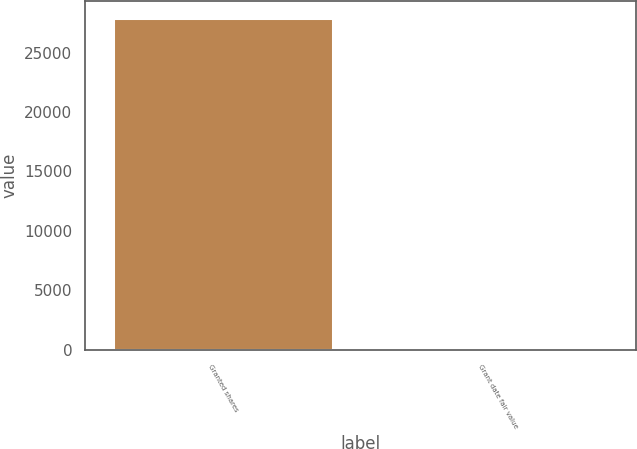Convert chart. <chart><loc_0><loc_0><loc_500><loc_500><bar_chart><fcel>Granted shares<fcel>Grant date fair value<nl><fcel>27931<fcel>20.62<nl></chart> 